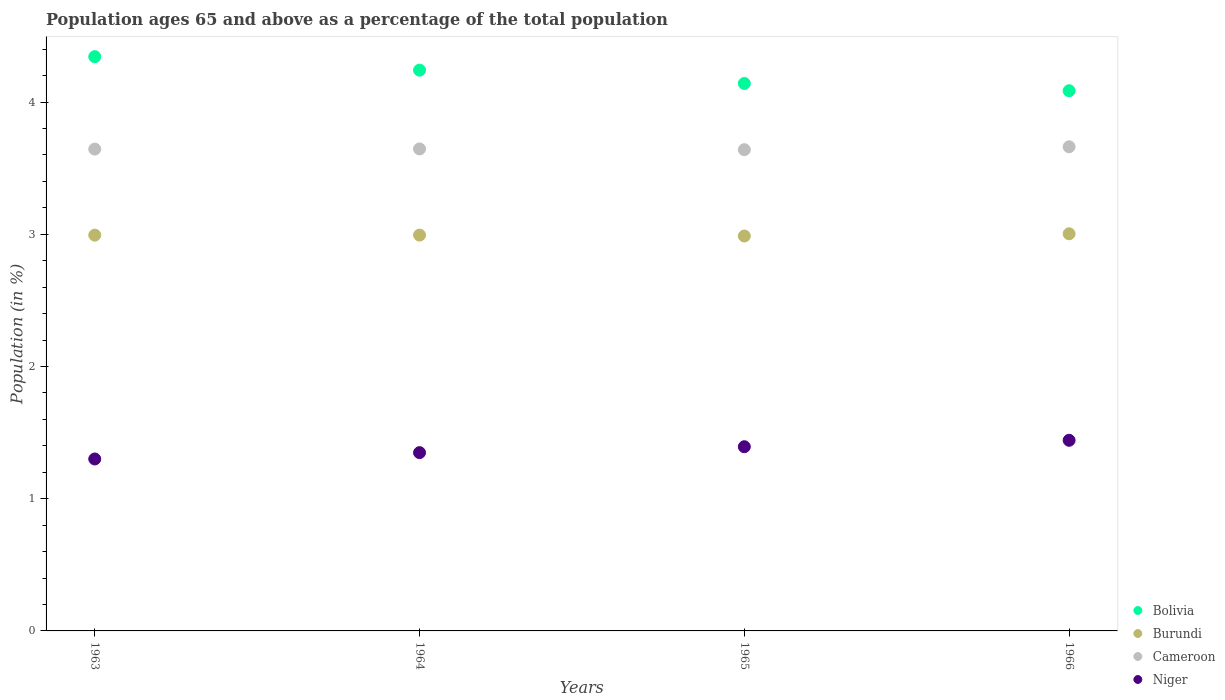Is the number of dotlines equal to the number of legend labels?
Your answer should be compact. Yes. What is the percentage of the population ages 65 and above in Niger in 1966?
Offer a very short reply. 1.44. Across all years, what is the maximum percentage of the population ages 65 and above in Burundi?
Make the answer very short. 3. Across all years, what is the minimum percentage of the population ages 65 and above in Niger?
Make the answer very short. 1.3. In which year was the percentage of the population ages 65 and above in Burundi maximum?
Keep it short and to the point. 1966. In which year was the percentage of the population ages 65 and above in Bolivia minimum?
Offer a terse response. 1966. What is the total percentage of the population ages 65 and above in Cameroon in the graph?
Make the answer very short. 14.59. What is the difference between the percentage of the population ages 65 and above in Niger in 1963 and that in 1966?
Keep it short and to the point. -0.14. What is the difference between the percentage of the population ages 65 and above in Bolivia in 1966 and the percentage of the population ages 65 and above in Cameroon in 1965?
Make the answer very short. 0.45. What is the average percentage of the population ages 65 and above in Burundi per year?
Offer a very short reply. 2.99. In the year 1965, what is the difference between the percentage of the population ages 65 and above in Burundi and percentage of the population ages 65 and above in Cameroon?
Your response must be concise. -0.65. In how many years, is the percentage of the population ages 65 and above in Niger greater than 1.6?
Keep it short and to the point. 0. What is the ratio of the percentage of the population ages 65 and above in Burundi in 1963 to that in 1966?
Give a very brief answer. 1. Is the difference between the percentage of the population ages 65 and above in Burundi in 1965 and 1966 greater than the difference between the percentage of the population ages 65 and above in Cameroon in 1965 and 1966?
Provide a short and direct response. Yes. What is the difference between the highest and the second highest percentage of the population ages 65 and above in Bolivia?
Offer a very short reply. 0.1. What is the difference between the highest and the lowest percentage of the population ages 65 and above in Niger?
Keep it short and to the point. 0.14. Is it the case that in every year, the sum of the percentage of the population ages 65 and above in Bolivia and percentage of the population ages 65 and above in Burundi  is greater than the sum of percentage of the population ages 65 and above in Cameroon and percentage of the population ages 65 and above in Niger?
Give a very brief answer. No. Is it the case that in every year, the sum of the percentage of the population ages 65 and above in Bolivia and percentage of the population ages 65 and above in Burundi  is greater than the percentage of the population ages 65 and above in Cameroon?
Your response must be concise. Yes. Does the percentage of the population ages 65 and above in Burundi monotonically increase over the years?
Your response must be concise. No. Is the percentage of the population ages 65 and above in Burundi strictly greater than the percentage of the population ages 65 and above in Cameroon over the years?
Keep it short and to the point. No. Is the percentage of the population ages 65 and above in Cameroon strictly less than the percentage of the population ages 65 and above in Bolivia over the years?
Ensure brevity in your answer.  Yes. How many dotlines are there?
Make the answer very short. 4. What is the difference between two consecutive major ticks on the Y-axis?
Your response must be concise. 1. Are the values on the major ticks of Y-axis written in scientific E-notation?
Your answer should be compact. No. Does the graph contain any zero values?
Offer a terse response. No. Where does the legend appear in the graph?
Keep it short and to the point. Bottom right. What is the title of the graph?
Your answer should be very brief. Population ages 65 and above as a percentage of the total population. Does "Malawi" appear as one of the legend labels in the graph?
Your answer should be compact. No. What is the Population (in %) in Bolivia in 1963?
Make the answer very short. 4.34. What is the Population (in %) of Burundi in 1963?
Ensure brevity in your answer.  2.99. What is the Population (in %) of Cameroon in 1963?
Offer a terse response. 3.64. What is the Population (in %) of Niger in 1963?
Your answer should be very brief. 1.3. What is the Population (in %) in Bolivia in 1964?
Your response must be concise. 4.24. What is the Population (in %) in Burundi in 1964?
Your answer should be compact. 2.99. What is the Population (in %) in Cameroon in 1964?
Give a very brief answer. 3.65. What is the Population (in %) in Niger in 1964?
Your answer should be compact. 1.35. What is the Population (in %) in Bolivia in 1965?
Your answer should be very brief. 4.14. What is the Population (in %) in Burundi in 1965?
Keep it short and to the point. 2.99. What is the Population (in %) in Cameroon in 1965?
Ensure brevity in your answer.  3.64. What is the Population (in %) of Niger in 1965?
Your answer should be very brief. 1.39. What is the Population (in %) in Bolivia in 1966?
Give a very brief answer. 4.09. What is the Population (in %) in Burundi in 1966?
Your response must be concise. 3. What is the Population (in %) in Cameroon in 1966?
Keep it short and to the point. 3.66. What is the Population (in %) in Niger in 1966?
Give a very brief answer. 1.44. Across all years, what is the maximum Population (in %) in Bolivia?
Offer a very short reply. 4.34. Across all years, what is the maximum Population (in %) of Burundi?
Offer a terse response. 3. Across all years, what is the maximum Population (in %) in Cameroon?
Offer a very short reply. 3.66. Across all years, what is the maximum Population (in %) of Niger?
Ensure brevity in your answer.  1.44. Across all years, what is the minimum Population (in %) in Bolivia?
Give a very brief answer. 4.09. Across all years, what is the minimum Population (in %) in Burundi?
Provide a succinct answer. 2.99. Across all years, what is the minimum Population (in %) in Cameroon?
Ensure brevity in your answer.  3.64. Across all years, what is the minimum Population (in %) of Niger?
Offer a terse response. 1.3. What is the total Population (in %) in Bolivia in the graph?
Offer a terse response. 16.81. What is the total Population (in %) of Burundi in the graph?
Keep it short and to the point. 11.98. What is the total Population (in %) in Cameroon in the graph?
Provide a short and direct response. 14.59. What is the total Population (in %) of Niger in the graph?
Your answer should be compact. 5.48. What is the difference between the Population (in %) in Bolivia in 1963 and that in 1964?
Your response must be concise. 0.1. What is the difference between the Population (in %) in Burundi in 1963 and that in 1964?
Give a very brief answer. -0. What is the difference between the Population (in %) of Cameroon in 1963 and that in 1964?
Offer a terse response. -0. What is the difference between the Population (in %) in Niger in 1963 and that in 1964?
Give a very brief answer. -0.05. What is the difference between the Population (in %) in Bolivia in 1963 and that in 1965?
Provide a short and direct response. 0.2. What is the difference between the Population (in %) of Burundi in 1963 and that in 1965?
Ensure brevity in your answer.  0.01. What is the difference between the Population (in %) in Cameroon in 1963 and that in 1965?
Give a very brief answer. 0. What is the difference between the Population (in %) in Niger in 1963 and that in 1965?
Your response must be concise. -0.09. What is the difference between the Population (in %) of Bolivia in 1963 and that in 1966?
Make the answer very short. 0.26. What is the difference between the Population (in %) in Burundi in 1963 and that in 1966?
Your response must be concise. -0.01. What is the difference between the Population (in %) of Cameroon in 1963 and that in 1966?
Your response must be concise. -0.02. What is the difference between the Population (in %) of Niger in 1963 and that in 1966?
Ensure brevity in your answer.  -0.14. What is the difference between the Population (in %) of Bolivia in 1964 and that in 1965?
Offer a very short reply. 0.1. What is the difference between the Population (in %) in Burundi in 1964 and that in 1965?
Offer a terse response. 0.01. What is the difference between the Population (in %) in Cameroon in 1964 and that in 1965?
Make the answer very short. 0.01. What is the difference between the Population (in %) in Niger in 1964 and that in 1965?
Offer a very short reply. -0.04. What is the difference between the Population (in %) of Bolivia in 1964 and that in 1966?
Provide a short and direct response. 0.16. What is the difference between the Population (in %) of Burundi in 1964 and that in 1966?
Provide a succinct answer. -0.01. What is the difference between the Population (in %) of Cameroon in 1964 and that in 1966?
Give a very brief answer. -0.02. What is the difference between the Population (in %) of Niger in 1964 and that in 1966?
Ensure brevity in your answer.  -0.09. What is the difference between the Population (in %) in Bolivia in 1965 and that in 1966?
Offer a terse response. 0.05. What is the difference between the Population (in %) of Burundi in 1965 and that in 1966?
Give a very brief answer. -0.02. What is the difference between the Population (in %) in Cameroon in 1965 and that in 1966?
Give a very brief answer. -0.02. What is the difference between the Population (in %) of Niger in 1965 and that in 1966?
Keep it short and to the point. -0.05. What is the difference between the Population (in %) of Bolivia in 1963 and the Population (in %) of Burundi in 1964?
Offer a terse response. 1.35. What is the difference between the Population (in %) in Bolivia in 1963 and the Population (in %) in Cameroon in 1964?
Your response must be concise. 0.7. What is the difference between the Population (in %) of Bolivia in 1963 and the Population (in %) of Niger in 1964?
Your response must be concise. 3. What is the difference between the Population (in %) of Burundi in 1963 and the Population (in %) of Cameroon in 1964?
Your answer should be very brief. -0.65. What is the difference between the Population (in %) in Burundi in 1963 and the Population (in %) in Niger in 1964?
Offer a terse response. 1.65. What is the difference between the Population (in %) of Cameroon in 1963 and the Population (in %) of Niger in 1964?
Your answer should be very brief. 2.3. What is the difference between the Population (in %) of Bolivia in 1963 and the Population (in %) of Burundi in 1965?
Offer a terse response. 1.36. What is the difference between the Population (in %) of Bolivia in 1963 and the Population (in %) of Cameroon in 1965?
Your answer should be very brief. 0.7. What is the difference between the Population (in %) of Bolivia in 1963 and the Population (in %) of Niger in 1965?
Offer a very short reply. 2.95. What is the difference between the Population (in %) of Burundi in 1963 and the Population (in %) of Cameroon in 1965?
Give a very brief answer. -0.65. What is the difference between the Population (in %) of Burundi in 1963 and the Population (in %) of Niger in 1965?
Provide a short and direct response. 1.6. What is the difference between the Population (in %) in Cameroon in 1963 and the Population (in %) in Niger in 1965?
Offer a terse response. 2.25. What is the difference between the Population (in %) in Bolivia in 1963 and the Population (in %) in Burundi in 1966?
Your answer should be very brief. 1.34. What is the difference between the Population (in %) of Bolivia in 1963 and the Population (in %) of Cameroon in 1966?
Your answer should be compact. 0.68. What is the difference between the Population (in %) in Bolivia in 1963 and the Population (in %) in Niger in 1966?
Offer a terse response. 2.9. What is the difference between the Population (in %) in Burundi in 1963 and the Population (in %) in Cameroon in 1966?
Keep it short and to the point. -0.67. What is the difference between the Population (in %) of Burundi in 1963 and the Population (in %) of Niger in 1966?
Your answer should be very brief. 1.55. What is the difference between the Population (in %) of Cameroon in 1963 and the Population (in %) of Niger in 1966?
Your answer should be very brief. 2.2. What is the difference between the Population (in %) of Bolivia in 1964 and the Population (in %) of Burundi in 1965?
Keep it short and to the point. 1.25. What is the difference between the Population (in %) of Bolivia in 1964 and the Population (in %) of Cameroon in 1965?
Provide a succinct answer. 0.6. What is the difference between the Population (in %) of Bolivia in 1964 and the Population (in %) of Niger in 1965?
Your answer should be very brief. 2.85. What is the difference between the Population (in %) in Burundi in 1964 and the Population (in %) in Cameroon in 1965?
Your answer should be compact. -0.65. What is the difference between the Population (in %) of Burundi in 1964 and the Population (in %) of Niger in 1965?
Give a very brief answer. 1.6. What is the difference between the Population (in %) of Cameroon in 1964 and the Population (in %) of Niger in 1965?
Keep it short and to the point. 2.25. What is the difference between the Population (in %) in Bolivia in 1964 and the Population (in %) in Burundi in 1966?
Your answer should be very brief. 1.24. What is the difference between the Population (in %) in Bolivia in 1964 and the Population (in %) in Cameroon in 1966?
Offer a terse response. 0.58. What is the difference between the Population (in %) of Bolivia in 1964 and the Population (in %) of Niger in 1966?
Keep it short and to the point. 2.8. What is the difference between the Population (in %) of Burundi in 1964 and the Population (in %) of Cameroon in 1966?
Make the answer very short. -0.67. What is the difference between the Population (in %) of Burundi in 1964 and the Population (in %) of Niger in 1966?
Offer a terse response. 1.55. What is the difference between the Population (in %) of Cameroon in 1964 and the Population (in %) of Niger in 1966?
Provide a succinct answer. 2.2. What is the difference between the Population (in %) of Bolivia in 1965 and the Population (in %) of Burundi in 1966?
Your answer should be compact. 1.14. What is the difference between the Population (in %) in Bolivia in 1965 and the Population (in %) in Cameroon in 1966?
Provide a short and direct response. 0.48. What is the difference between the Population (in %) in Bolivia in 1965 and the Population (in %) in Niger in 1966?
Provide a short and direct response. 2.7. What is the difference between the Population (in %) in Burundi in 1965 and the Population (in %) in Cameroon in 1966?
Ensure brevity in your answer.  -0.67. What is the difference between the Population (in %) in Burundi in 1965 and the Population (in %) in Niger in 1966?
Ensure brevity in your answer.  1.55. What is the difference between the Population (in %) of Cameroon in 1965 and the Population (in %) of Niger in 1966?
Your answer should be very brief. 2.2. What is the average Population (in %) in Bolivia per year?
Ensure brevity in your answer.  4.2. What is the average Population (in %) in Burundi per year?
Provide a short and direct response. 2.99. What is the average Population (in %) in Cameroon per year?
Provide a short and direct response. 3.65. What is the average Population (in %) of Niger per year?
Ensure brevity in your answer.  1.37. In the year 1963, what is the difference between the Population (in %) in Bolivia and Population (in %) in Burundi?
Provide a short and direct response. 1.35. In the year 1963, what is the difference between the Population (in %) of Bolivia and Population (in %) of Cameroon?
Offer a very short reply. 0.7. In the year 1963, what is the difference between the Population (in %) of Bolivia and Population (in %) of Niger?
Offer a terse response. 3.04. In the year 1963, what is the difference between the Population (in %) in Burundi and Population (in %) in Cameroon?
Your answer should be compact. -0.65. In the year 1963, what is the difference between the Population (in %) of Burundi and Population (in %) of Niger?
Provide a short and direct response. 1.69. In the year 1963, what is the difference between the Population (in %) of Cameroon and Population (in %) of Niger?
Provide a succinct answer. 2.34. In the year 1964, what is the difference between the Population (in %) in Bolivia and Population (in %) in Burundi?
Make the answer very short. 1.25. In the year 1964, what is the difference between the Population (in %) in Bolivia and Population (in %) in Cameroon?
Your answer should be very brief. 0.6. In the year 1964, what is the difference between the Population (in %) of Bolivia and Population (in %) of Niger?
Your answer should be compact. 2.89. In the year 1964, what is the difference between the Population (in %) in Burundi and Population (in %) in Cameroon?
Make the answer very short. -0.65. In the year 1964, what is the difference between the Population (in %) in Burundi and Population (in %) in Niger?
Make the answer very short. 1.65. In the year 1964, what is the difference between the Population (in %) in Cameroon and Population (in %) in Niger?
Give a very brief answer. 2.3. In the year 1965, what is the difference between the Population (in %) of Bolivia and Population (in %) of Burundi?
Your response must be concise. 1.15. In the year 1965, what is the difference between the Population (in %) of Bolivia and Population (in %) of Cameroon?
Your answer should be very brief. 0.5. In the year 1965, what is the difference between the Population (in %) in Bolivia and Population (in %) in Niger?
Your answer should be very brief. 2.75. In the year 1965, what is the difference between the Population (in %) of Burundi and Population (in %) of Cameroon?
Provide a short and direct response. -0.65. In the year 1965, what is the difference between the Population (in %) of Burundi and Population (in %) of Niger?
Provide a short and direct response. 1.59. In the year 1965, what is the difference between the Population (in %) in Cameroon and Population (in %) in Niger?
Offer a terse response. 2.25. In the year 1966, what is the difference between the Population (in %) of Bolivia and Population (in %) of Burundi?
Provide a short and direct response. 1.08. In the year 1966, what is the difference between the Population (in %) of Bolivia and Population (in %) of Cameroon?
Make the answer very short. 0.42. In the year 1966, what is the difference between the Population (in %) of Bolivia and Population (in %) of Niger?
Your answer should be very brief. 2.64. In the year 1966, what is the difference between the Population (in %) in Burundi and Population (in %) in Cameroon?
Your answer should be compact. -0.66. In the year 1966, what is the difference between the Population (in %) in Burundi and Population (in %) in Niger?
Ensure brevity in your answer.  1.56. In the year 1966, what is the difference between the Population (in %) in Cameroon and Population (in %) in Niger?
Provide a short and direct response. 2.22. What is the ratio of the Population (in %) in Burundi in 1963 to that in 1964?
Offer a very short reply. 1. What is the ratio of the Population (in %) in Cameroon in 1963 to that in 1964?
Ensure brevity in your answer.  1. What is the ratio of the Population (in %) in Niger in 1963 to that in 1964?
Offer a terse response. 0.96. What is the ratio of the Population (in %) of Bolivia in 1963 to that in 1965?
Ensure brevity in your answer.  1.05. What is the ratio of the Population (in %) of Burundi in 1963 to that in 1965?
Your response must be concise. 1. What is the ratio of the Population (in %) of Cameroon in 1963 to that in 1965?
Ensure brevity in your answer.  1. What is the ratio of the Population (in %) in Niger in 1963 to that in 1965?
Your answer should be compact. 0.93. What is the ratio of the Population (in %) in Bolivia in 1963 to that in 1966?
Give a very brief answer. 1.06. What is the ratio of the Population (in %) of Niger in 1963 to that in 1966?
Give a very brief answer. 0.9. What is the ratio of the Population (in %) in Bolivia in 1964 to that in 1965?
Your answer should be compact. 1.02. What is the ratio of the Population (in %) of Cameroon in 1964 to that in 1965?
Provide a short and direct response. 1. What is the ratio of the Population (in %) in Niger in 1964 to that in 1965?
Your answer should be compact. 0.97. What is the ratio of the Population (in %) of Bolivia in 1964 to that in 1966?
Provide a short and direct response. 1.04. What is the ratio of the Population (in %) in Niger in 1964 to that in 1966?
Provide a succinct answer. 0.94. What is the ratio of the Population (in %) in Bolivia in 1965 to that in 1966?
Offer a terse response. 1.01. What is the ratio of the Population (in %) of Cameroon in 1965 to that in 1966?
Offer a very short reply. 0.99. What is the ratio of the Population (in %) in Niger in 1965 to that in 1966?
Offer a very short reply. 0.97. What is the difference between the highest and the second highest Population (in %) in Bolivia?
Keep it short and to the point. 0.1. What is the difference between the highest and the second highest Population (in %) in Cameroon?
Keep it short and to the point. 0.02. What is the difference between the highest and the second highest Population (in %) of Niger?
Your answer should be very brief. 0.05. What is the difference between the highest and the lowest Population (in %) of Bolivia?
Ensure brevity in your answer.  0.26. What is the difference between the highest and the lowest Population (in %) of Burundi?
Provide a short and direct response. 0.02. What is the difference between the highest and the lowest Population (in %) in Cameroon?
Your answer should be compact. 0.02. What is the difference between the highest and the lowest Population (in %) of Niger?
Make the answer very short. 0.14. 